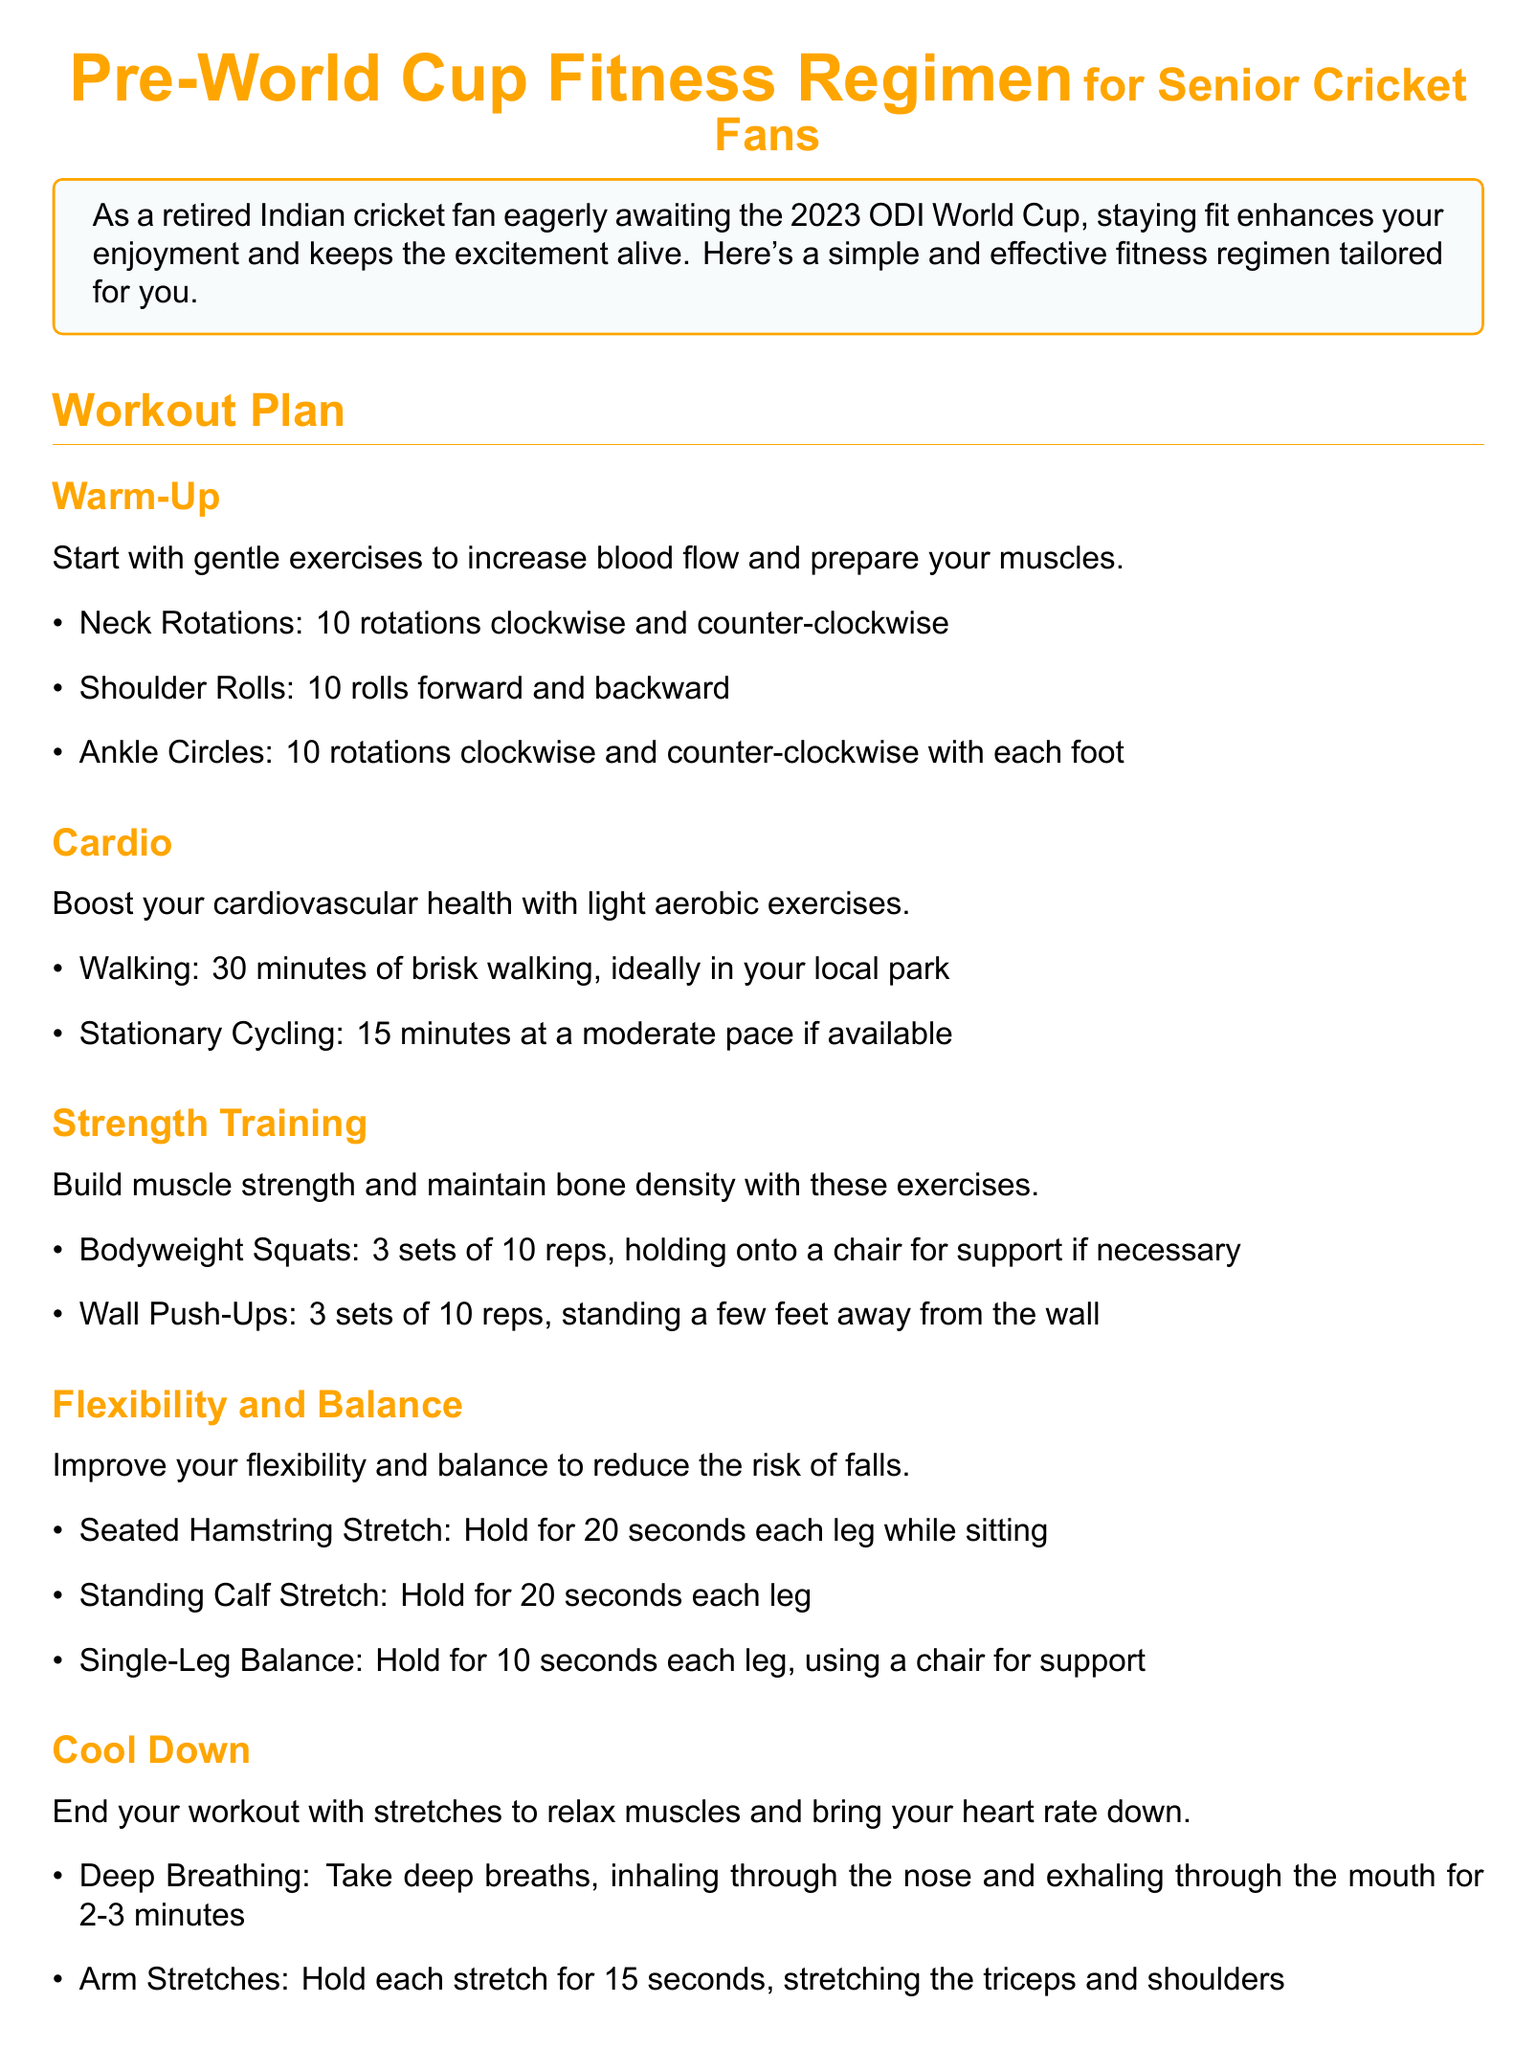What is the title of the document? The title of the document is presented at the top, emphasizing the focus on fitness for senior cricket fans.
Answer: Pre-World Cup Fitness Regimen for Senior Cricket Fans How long should the brisk walking last? The document specifies the duration of brisk walking in the cardio section.
Answer: 30 minutes What type of stretch is recommended for hamstrings? The document mentions specific stretches under the flexibility and balance section, including one for hamstrings.
Answer: Seated Hamstring Stretch How many sets of bodyweight squats are suggested? The strength training section indicates the recommended number of sets for bodyweight squats.
Answer: 3 sets What is the ideal frequency for following the regimen? The important notes section advises on how often to follow the workout plan for best results.
Answer: 3-4 times a week What nutrition tip is provided regarding hydration? The nutrition tips section includes advice about water intake during workouts.
Answer: Drink plenty of water What should you do if you experience pain during exercise? The important notes indicate the recommended action if there is pain or discomfort while exercising.
Answer: Stop immediately and consult with a healthcare professional How long should the deep breathing last during cool down? The document provides instructions for the duration of deep breathing in the cool down section.
Answer: 2-3 minutes 